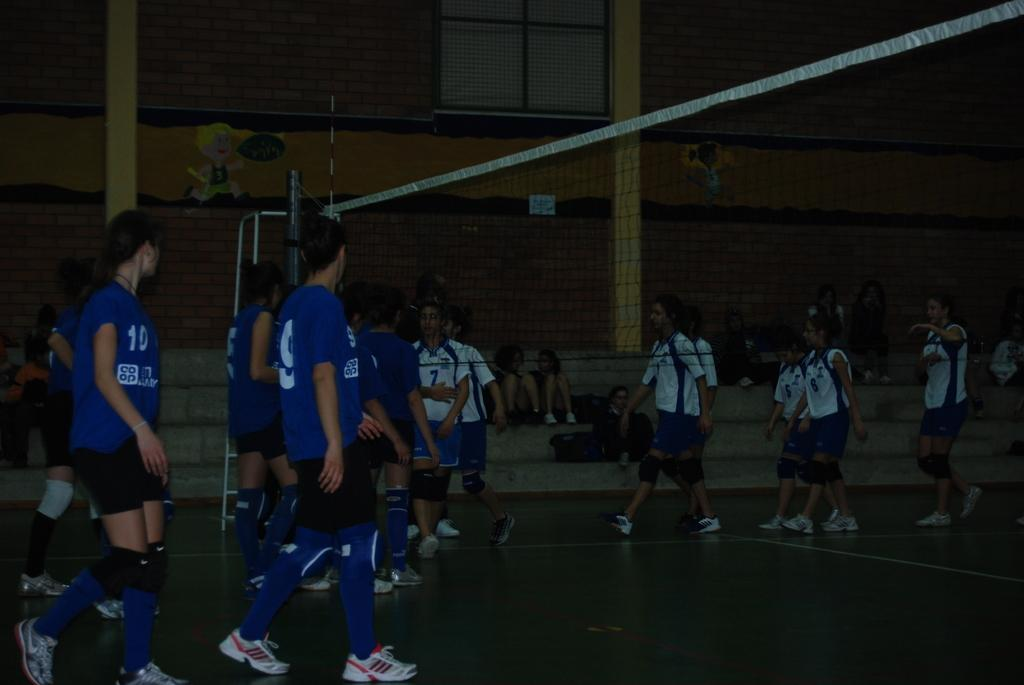What is present in the image that might be used for catching or holding objects? There is a net in the image. What structure can be seen in the image that might be used for supporting or displaying items? There is a stand in the image. What architectural feature is visible in the image that allows light to enter the space? There is a window in the image. What objects are present in the image that might be used for carrying or storing items? There are bags in the image. What type of structural element can be seen in the image that provides support and stability? There are pillars in the image. What decorative elements are present on the wall in the image? There are stickers on the wall in the image. How many people are present in the image? There is a group of people in the image. What are some of the people in the image doing? Some people are sitting on steps, and some people are walking on the ground in the image. What type of teaching activity is taking place in the image? There is no teaching activity present in the image. Can you describe the argument that is occurring between the people in the image? There is no argument present in the image; people are either sitting or walking. 